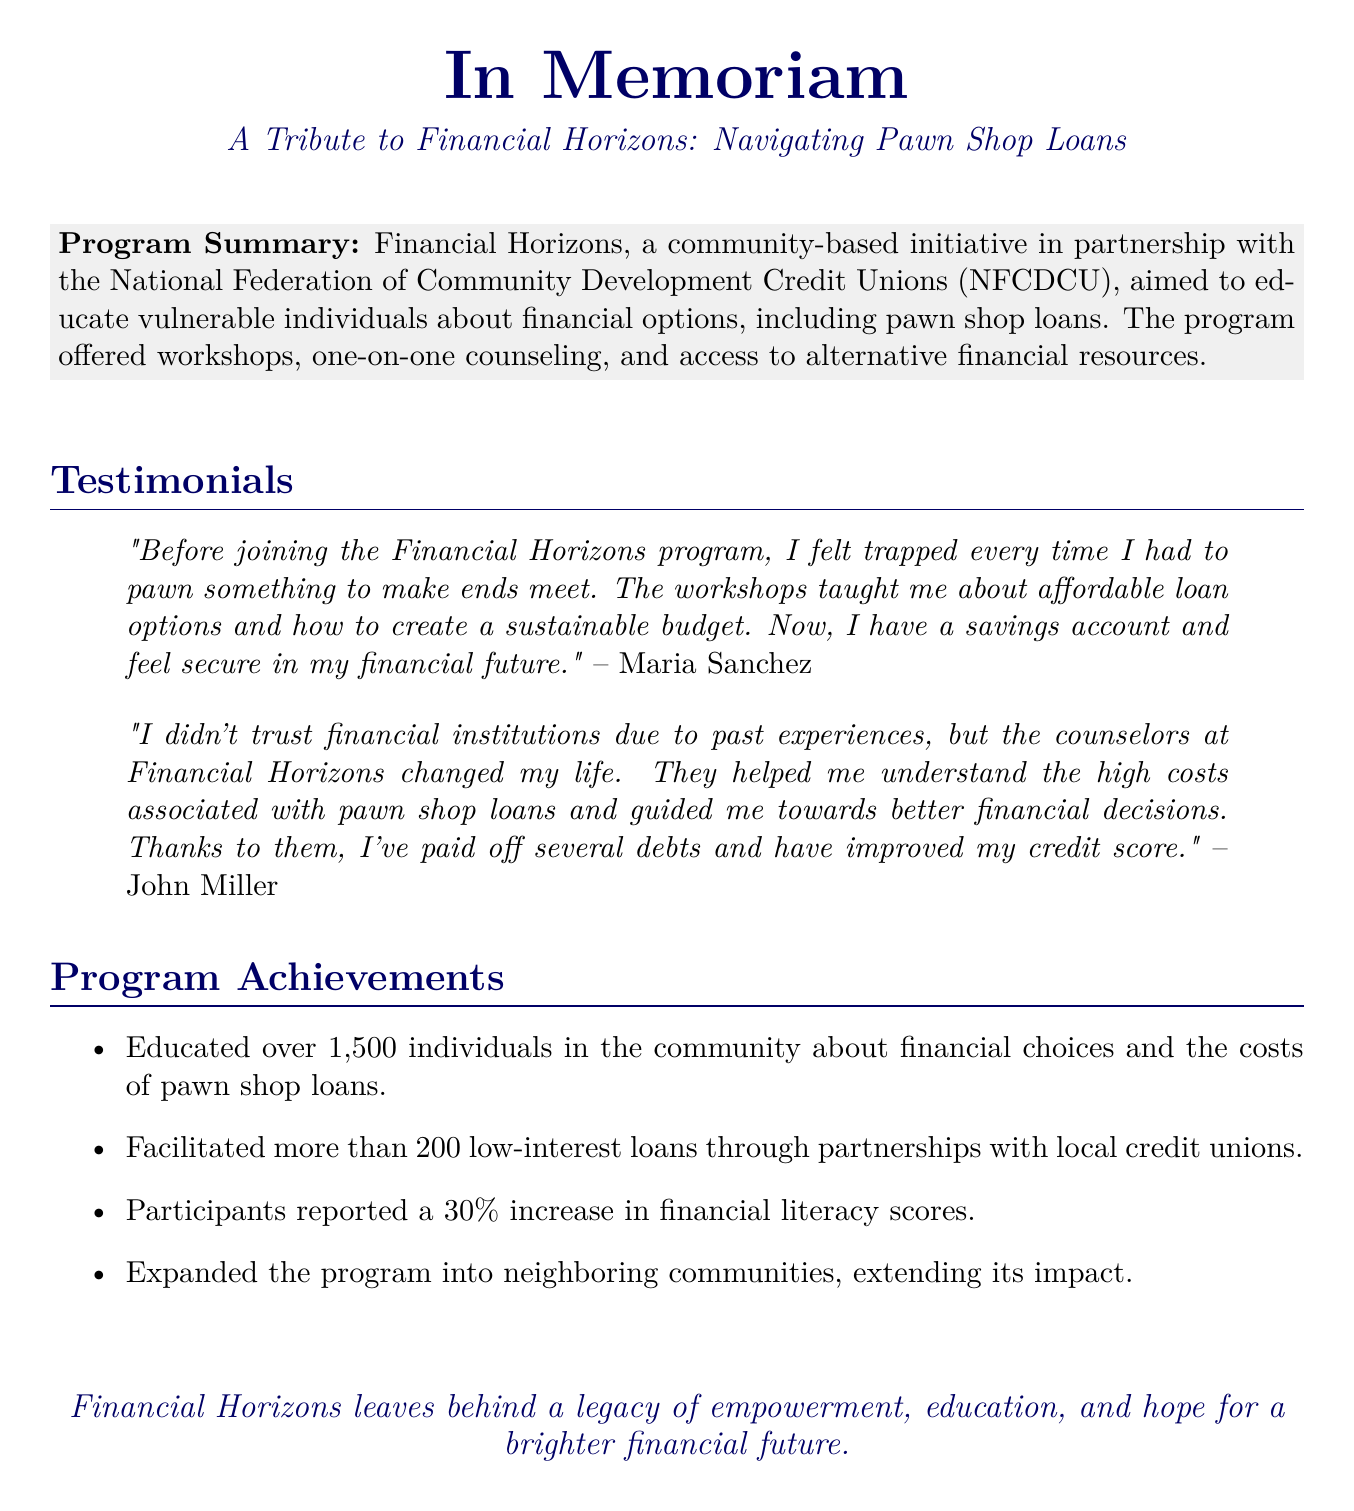What is the name of the program? The program is called Financial Horizons.
Answer: Financial Horizons How many individuals were educated through the program? The document states that over 1,500 individuals were educated in the community.
Answer: 1,500 Who partnered with Financial Horizons for this initiative? The National Federation of Community Development Credit Unions (NFCDCU) is mentioned as a partner.
Answer: NFCDCU What percentage increase in financial literacy scores was reported by participants? The document notes that participants reported a 30% increase.
Answer: 30% What did Maria Sanchez feel before joining the program? She felt trapped when she had to pawn something to make ends meet.
Answer: Trapped What type of loans were facilitated through partnerships with local credit unions? The program facilitated low-interest loans.
Answer: Low-interest loans What impact did the program have on neighboring communities? The program expanded into neighboring communities, extending its impact.
Answer: Expanded What is a key legacy left by Financial Horizons? The program leaves behind a legacy of empowerment, education, and hope.
Answer: Empowerment, education, and hope 